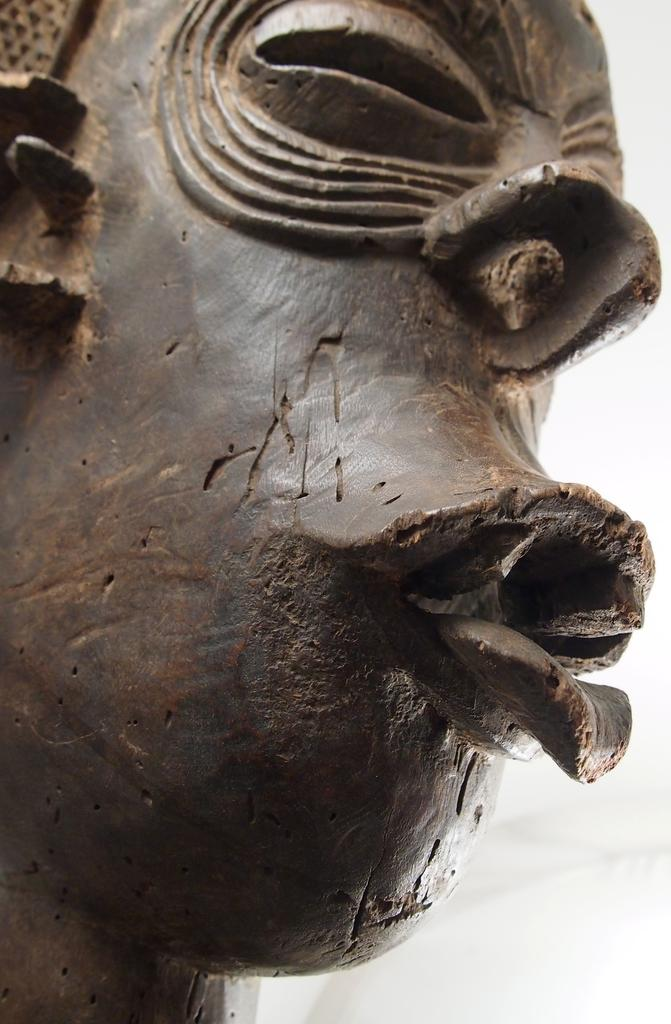What is the main subject in the foreground of the image? There is a sculpture in the foreground of the image. Can you describe the sculpture? The sculpture appears to be a face of a person. What is the color of the background in the image? The background of the image is white in color. How many rabbits can be seen playing with a board in the image? There are no rabbits or boards present in the image; it features a sculpture of a person's face in the foreground and a white background. Is there a shoe visible in the image? There is no shoe present in the image. 